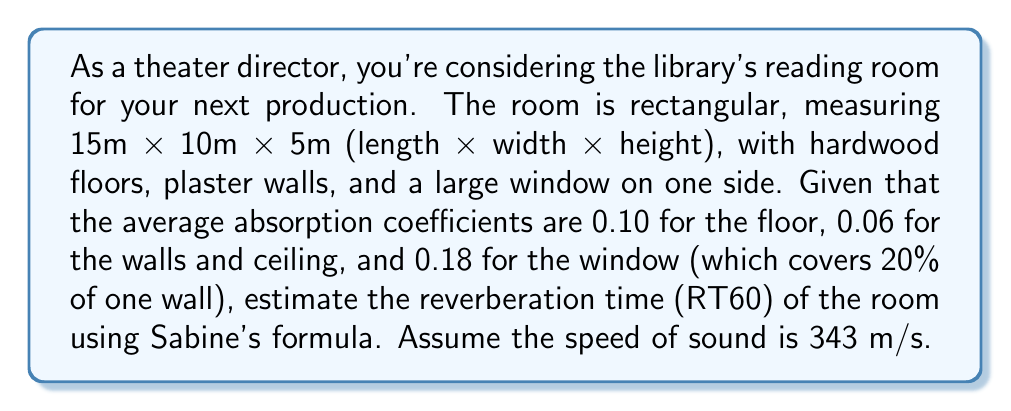Give your solution to this math problem. To estimate the reverberation time (RT60) using Sabine's formula, we need to follow these steps:

1. Calculate the total surface area of the room:
   Floor and ceiling: $2 * (15m * 10m) = 300 m^2$
   Walls: $2 * (15m * 5m) + 2 * (10m * 5m) = 250 m^2$
   Total surface area: $S_{total} = 300 + 250 = 550 m^2$

2. Calculate the area of the window:
   One wall area: $15m * 5m = 75 m^2$
   Window area: $20\% * 75 m^2 = 15 m^2$

3. Calculate the effective absorption area for each surface:
   Floor: $A_{floor} = 150 m^2 * 0.10 = 15 m^2$
   Ceiling: $A_{ceiling} = 150 m^2 * 0.06 = 9 m^2$
   Walls (excluding window): $A_{walls} = (250 m^2 - 15 m^2) * 0.06 = 14.1 m^2$
   Window: $A_{window} = 15 m^2 * 0.18 = 2.7 m^2$

4. Calculate the total effective absorption area:
   $A_{total} = 15 + 9 + 14.1 + 2.7 = 40.8 m^2$

5. Calculate the room volume:
   $V = 15m * 10m * 5m = 750 m^3$

6. Apply Sabine's formula:
   $RT60 = \frac{0.161 * V}{A_{total}}$

   Where:
   $RT60$ is the reverberation time in seconds
   $V$ is the room volume in cubic meters
   $A_{total}$ is the total effective absorption area in square meters

   $RT60 = \frac{0.161 * 750}{40.8} = 2.96$ seconds

Therefore, the estimated reverberation time (RT60) for the library's reading room is approximately 2.96 seconds.
Answer: $RT60 \approx 2.96$ seconds 